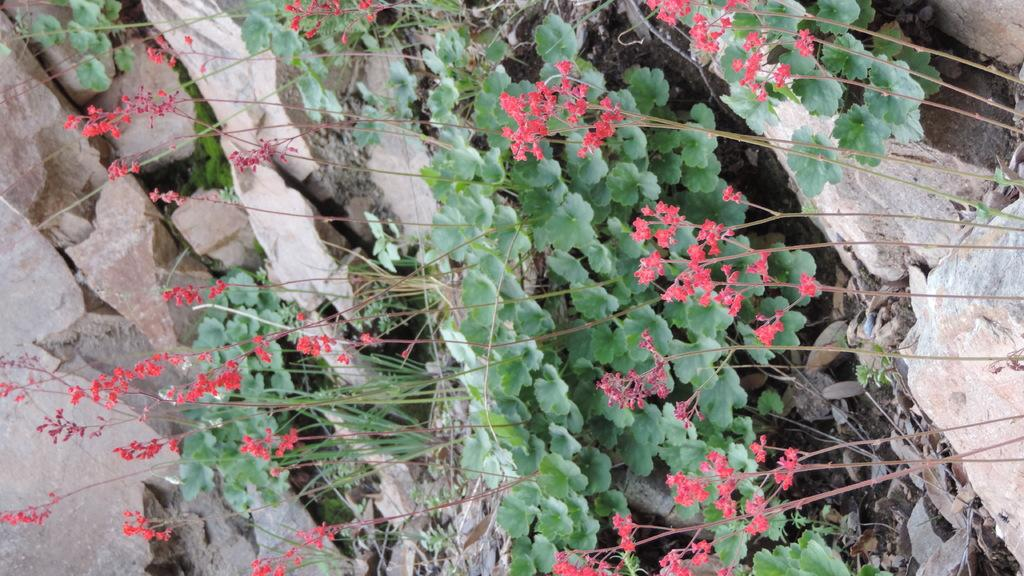What type of plants can be seen in the image? There are flower plants in the image. Where are the flower plants located? The flower plants are on a group of rocks. How many passengers are visible in the image? There are no passengers present in the image; it features flower plants on a group of rocks. What type of crate can be seen holding the flower plants? There is no crate present in the image; the flower plants are on a group of rocks. 